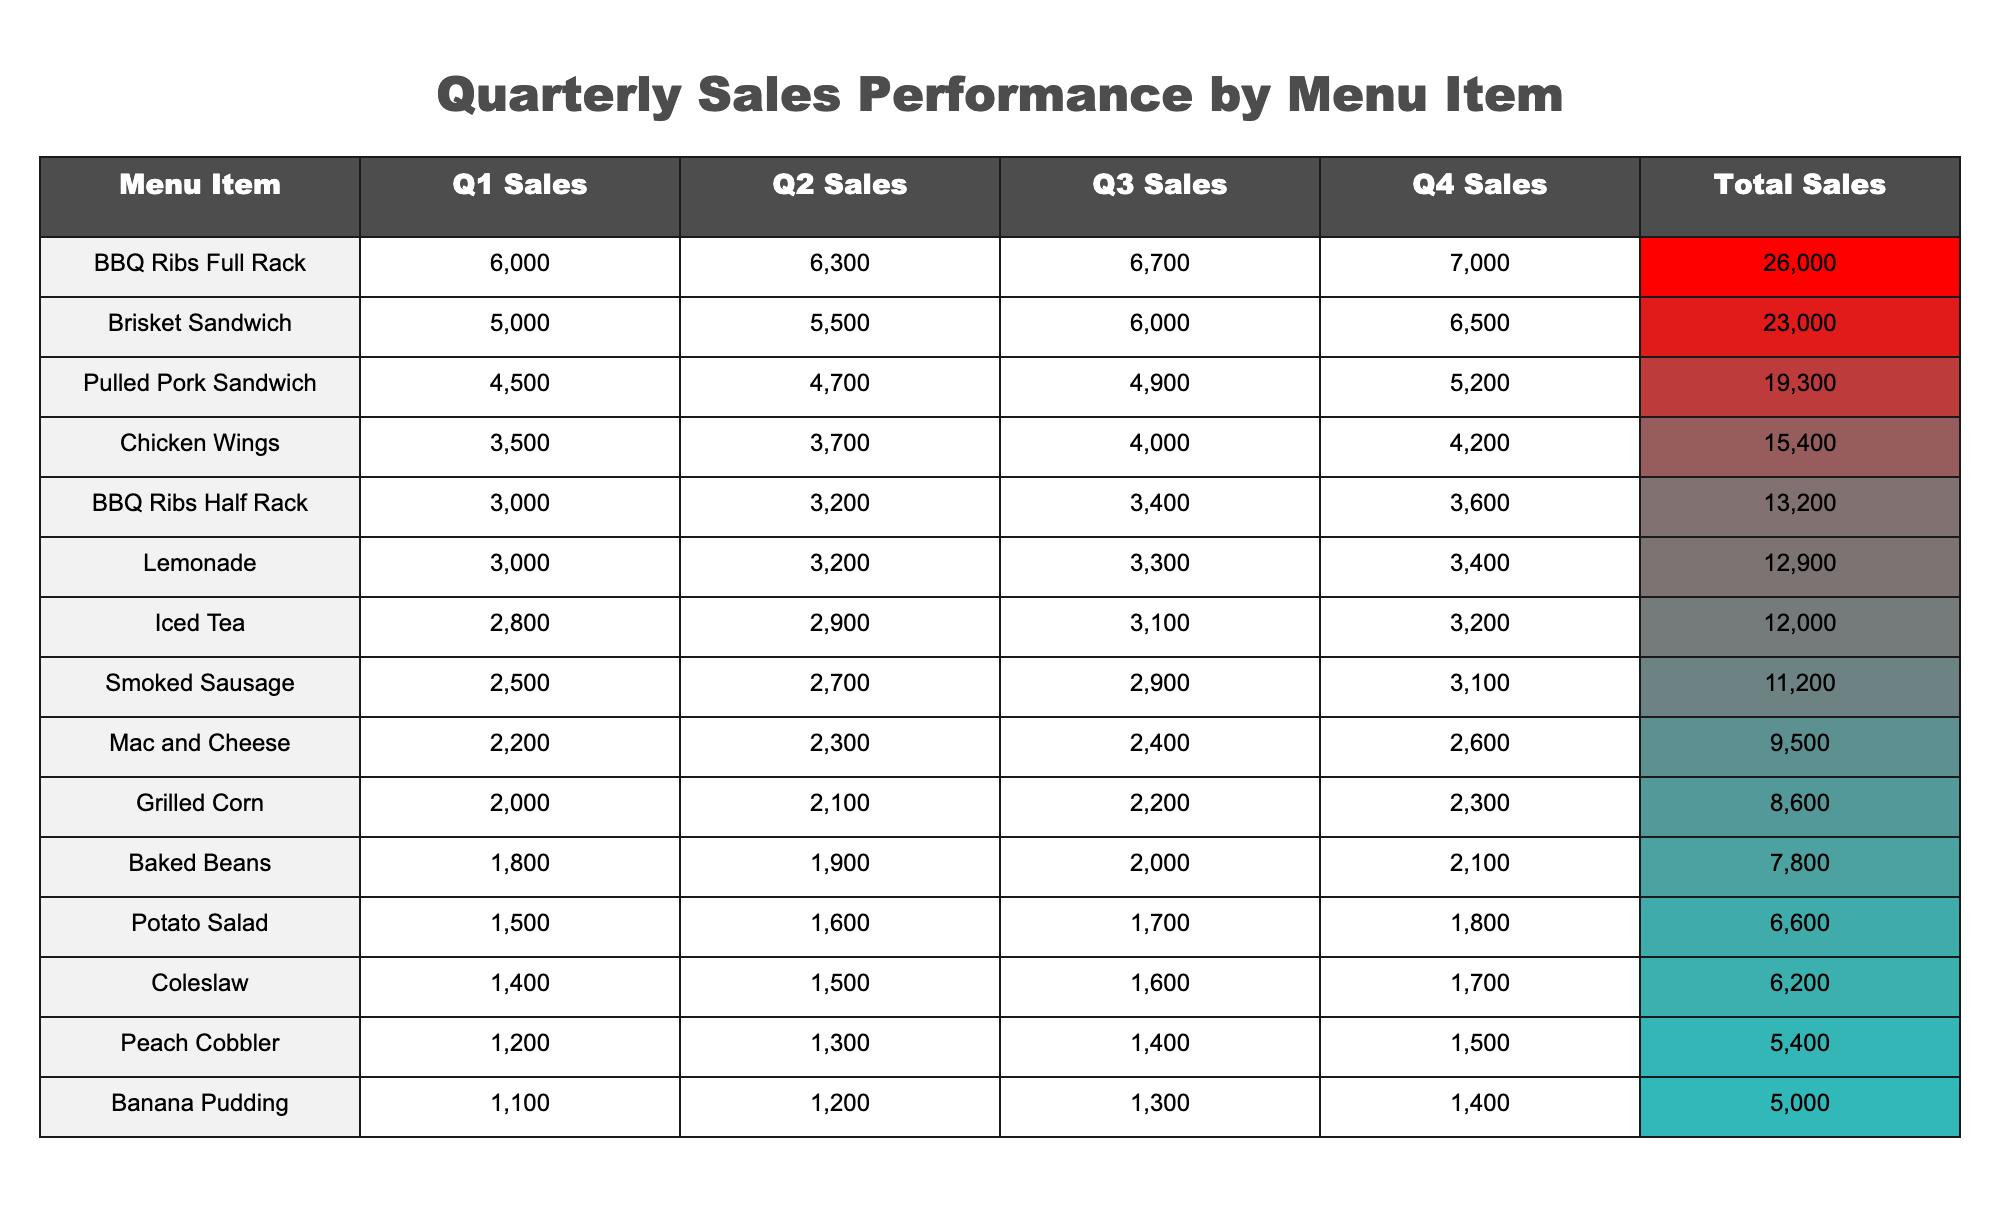What item had the highest total sales in the year? By inspecting the 'Total Sales' column in the table, it's clear that the "BBQ Ribs Full Rack" item has the highest total sales of 26,000.
Answer: BBQ Ribs Full Rack What was the total sales for the "Pulled Pork Sandwich"? To find the total sales, we add up the quarterly sales: 4500 + 4700 + 4900 + 5200 = 19300.
Answer: 19300 Which menu item showed the greatest increase in sales from Q1 to Q4? We look at the sales data for each item from Q1 to Q4. The "Brisket Sandwich" starts at 5000 and ends at 6500, an increase of 1500. The "BBQ Ribs Full Rack" starts at 6000 and ends at 7000, an increase of 1000. The greatest increase is from the "Brisket Sandwich".
Answer: Brisket Sandwich Is the total sales of "Mac and Cheese" greater than that of "Banana Pudding"? First, we calculate the total sales of "Mac and Cheese" which is 2200 + 2300 + 2400 + 2600 = 9500. For "Banana Pudding", it is 1100 + 1200 + 1300 + 1400 = 5000. Since 9500 is greater than 5000, the answer is yes.
Answer: Yes What is the average sales for the "Chicken Wings"? To calculate the average for "Chicken Wings", sum the quarterly sales: 3500 + 3700 + 4000 + 4200 = 15400, and divide by 4 (the number of quarters) to get 15400 / 4 = 3850.
Answer: 3850 Which items had total sales above 20000? We need to check each item’s total sales. The "BBQ Ribs Full Rack" (26000), "Brisket Sandwich" (23000), and "Pulled Pork Sandwich" (19300) are all present, and only "BBQ Ribs Full Rack" and "Brisket Sandwich" exceed 20000.
Answer: BBQ Ribs Full Rack, Brisket Sandwich Did total sales for "Grilled Corn" exceed that of "Coleslaw"? "Grilled Corn" total sales are 2000 + 2100 + 2200 + 2300 = 8600, while "Coleslaw" totals at 1400 + 1500 + 1600 + 1700 = 6200. Comparing these totals, 8600 is greater than 6200.
Answer: Yes What was the total revenue from the "Baked Beans" for the entire year? The total revenue for "Baked Beans" can be calculated by summing its quarterly sales: 1800 + 1900 + 2000 + 2100 = 8800.
Answer: 8800 